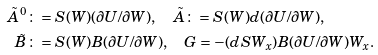<formula> <loc_0><loc_0><loc_500><loc_500>\tilde { A } ^ { 0 } & \colon = S ( W ) ( \partial U / \partial W ) , \quad \tilde { A } \colon = S ( W ) d ( \partial U / \partial W ) , \\ \tilde { B } & \colon = S ( W ) B ( \partial U / \partial W ) , \quad G = - ( d S W _ { x } ) B ( \partial U / \partial W ) W _ { x } .</formula> 